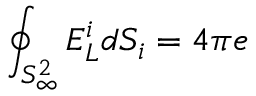<formula> <loc_0><loc_0><loc_500><loc_500>\oint _ { S _ { \infty } ^ { 2 } } E _ { L } ^ { i } d S _ { i } = 4 \pi e</formula> 